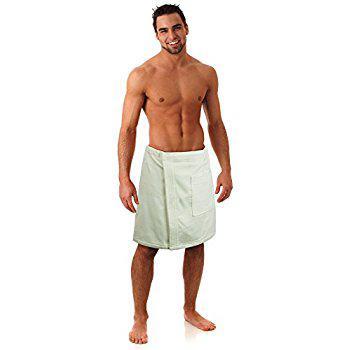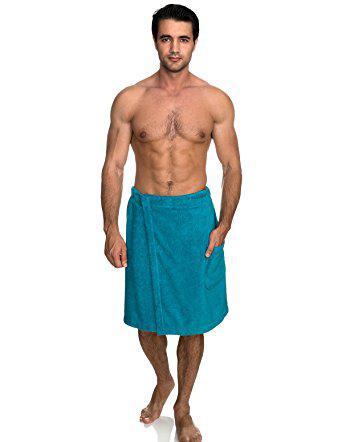The first image is the image on the left, the second image is the image on the right. For the images shown, is this caption "Every photo shows exactly one shirtless man modeling one towel around his waist and the towels are not the same color." true? Answer yes or no. Yes. The first image is the image on the left, the second image is the image on the right. For the images displayed, is the sentence "Each image shows one dark-haired man, who faces forward, wearing only a towel wrapped around his waist, and one image features a man wearing a white towel." factually correct? Answer yes or no. Yes. 